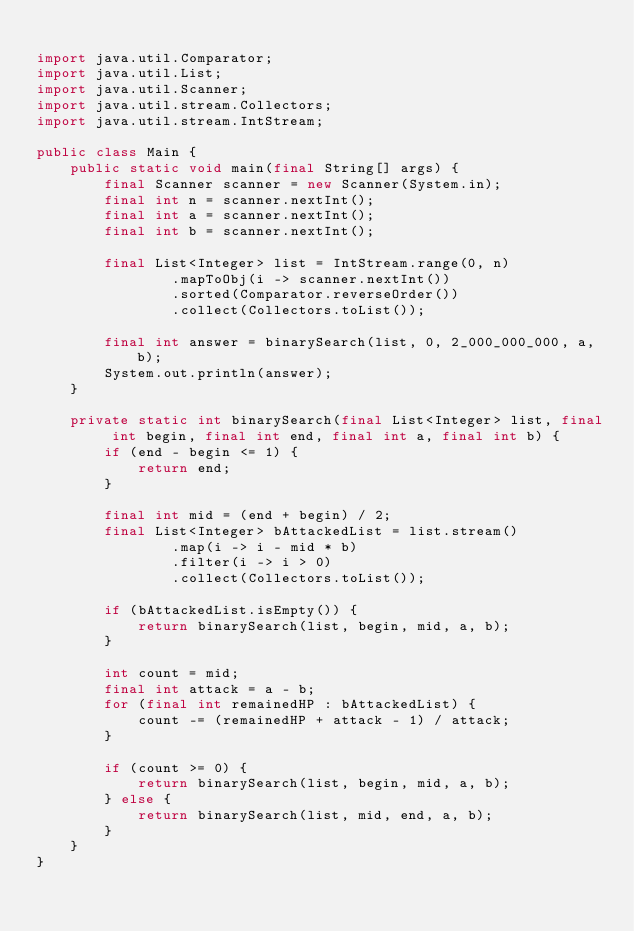<code> <loc_0><loc_0><loc_500><loc_500><_Java_>
import java.util.Comparator;
import java.util.List;
import java.util.Scanner;
import java.util.stream.Collectors;
import java.util.stream.IntStream;

public class Main {
    public static void main(final String[] args) {
        final Scanner scanner = new Scanner(System.in);
        final int n = scanner.nextInt();
        final int a = scanner.nextInt();
        final int b = scanner.nextInt();

        final List<Integer> list = IntStream.range(0, n)
                .mapToObj(i -> scanner.nextInt())
                .sorted(Comparator.reverseOrder())
                .collect(Collectors.toList());

        final int answer = binarySearch(list, 0, 2_000_000_000, a, b);
        System.out.println(answer);
    }

    private static int binarySearch(final List<Integer> list, final int begin, final int end, final int a, final int b) {
        if (end - begin <= 1) {
            return end;
        }

        final int mid = (end + begin) / 2;
        final List<Integer> bAttackedList = list.stream()
                .map(i -> i - mid * b)
                .filter(i -> i > 0)
                .collect(Collectors.toList());

        if (bAttackedList.isEmpty()) {
            return binarySearch(list, begin, mid, a, b);
        }

        int count = mid;
        final int attack = a - b;
        for (final int remainedHP : bAttackedList) {
            count -= (remainedHP + attack - 1) / attack;
        }

        if (count >= 0) {
            return binarySearch(list, begin, mid, a, b);
        } else {
            return binarySearch(list, mid, end, a, b);
        }
    }
}
</code> 